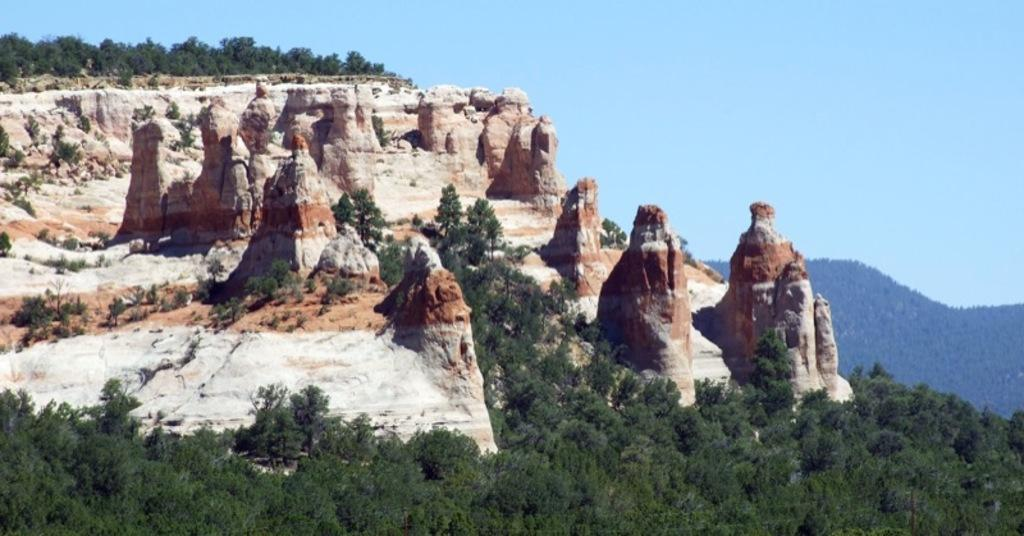What type of vegetation is at the bottom of the image? There are trees at the bottom of the image. What geographical features are in the middle of the image? There are hills in the middle of the image. What is visible at the top of the image? The sky is visible at the top of the image. What color is the ink on the tail of the animal in the image? There are no animals or ink present in the image; it features trees, hills, and the sky. 